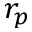<formula> <loc_0><loc_0><loc_500><loc_500>r _ { p }</formula> 